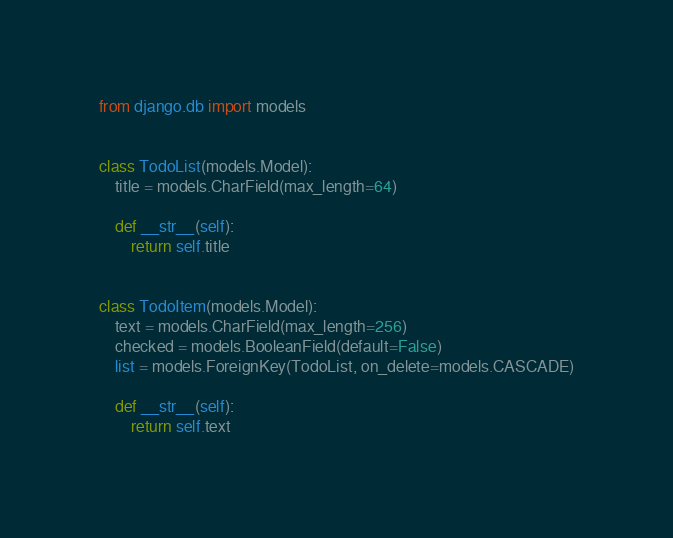<code> <loc_0><loc_0><loc_500><loc_500><_Python_>from django.db import models


class TodoList(models.Model):
    title = models.CharField(max_length=64)

    def __str__(self):
        return self.title


class TodoItem(models.Model):
    text = models.CharField(max_length=256)
    checked = models.BooleanField(default=False)
    list = models.ForeignKey(TodoList, on_delete=models.CASCADE)

    def __str__(self):
        return self.text
</code> 